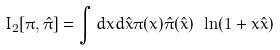Convert formula to latex. <formula><loc_0><loc_0><loc_500><loc_500>I _ { 2 } [ \pi , \hat { \pi } ] = \int d x d \hat { x } \pi ( x ) \hat { \pi } ( \hat { x } ) \ \ln ( 1 + x \hat { x } )</formula> 